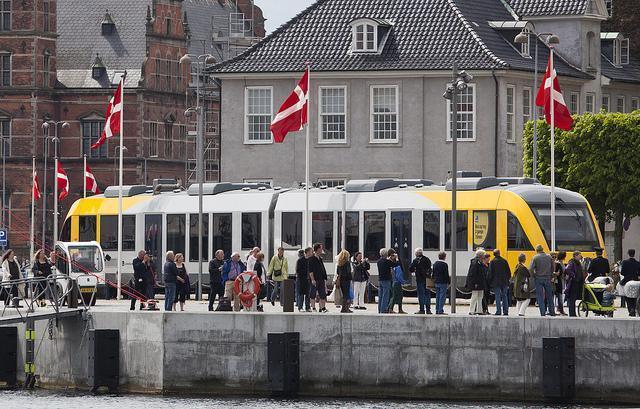How many red and white flags are there?
Give a very brief answer. 6. How many trains are there?
Give a very brief answer. 1. How many people can you see?
Give a very brief answer. 1. How many donuts have sprinkles on them?
Give a very brief answer. 0. 